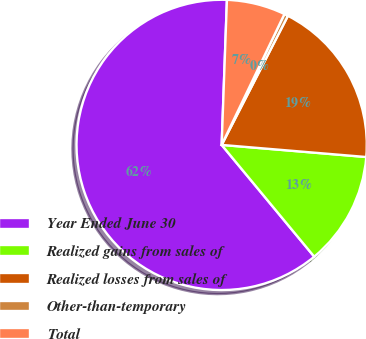Convert chart to OTSL. <chart><loc_0><loc_0><loc_500><loc_500><pie_chart><fcel>Year Ended June 30<fcel>Realized gains from sales of<fcel>Realized losses from sales of<fcel>Other-than-temporary<fcel>Total<nl><fcel>61.59%<fcel>12.66%<fcel>18.78%<fcel>0.43%<fcel>6.54%<nl></chart> 